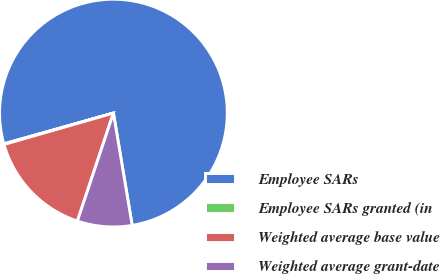<chart> <loc_0><loc_0><loc_500><loc_500><pie_chart><fcel>Employee SARs<fcel>Employee SARs granted (in<fcel>Weighted average base value<fcel>Weighted average grant-date<nl><fcel>76.71%<fcel>0.1%<fcel>15.42%<fcel>7.76%<nl></chart> 